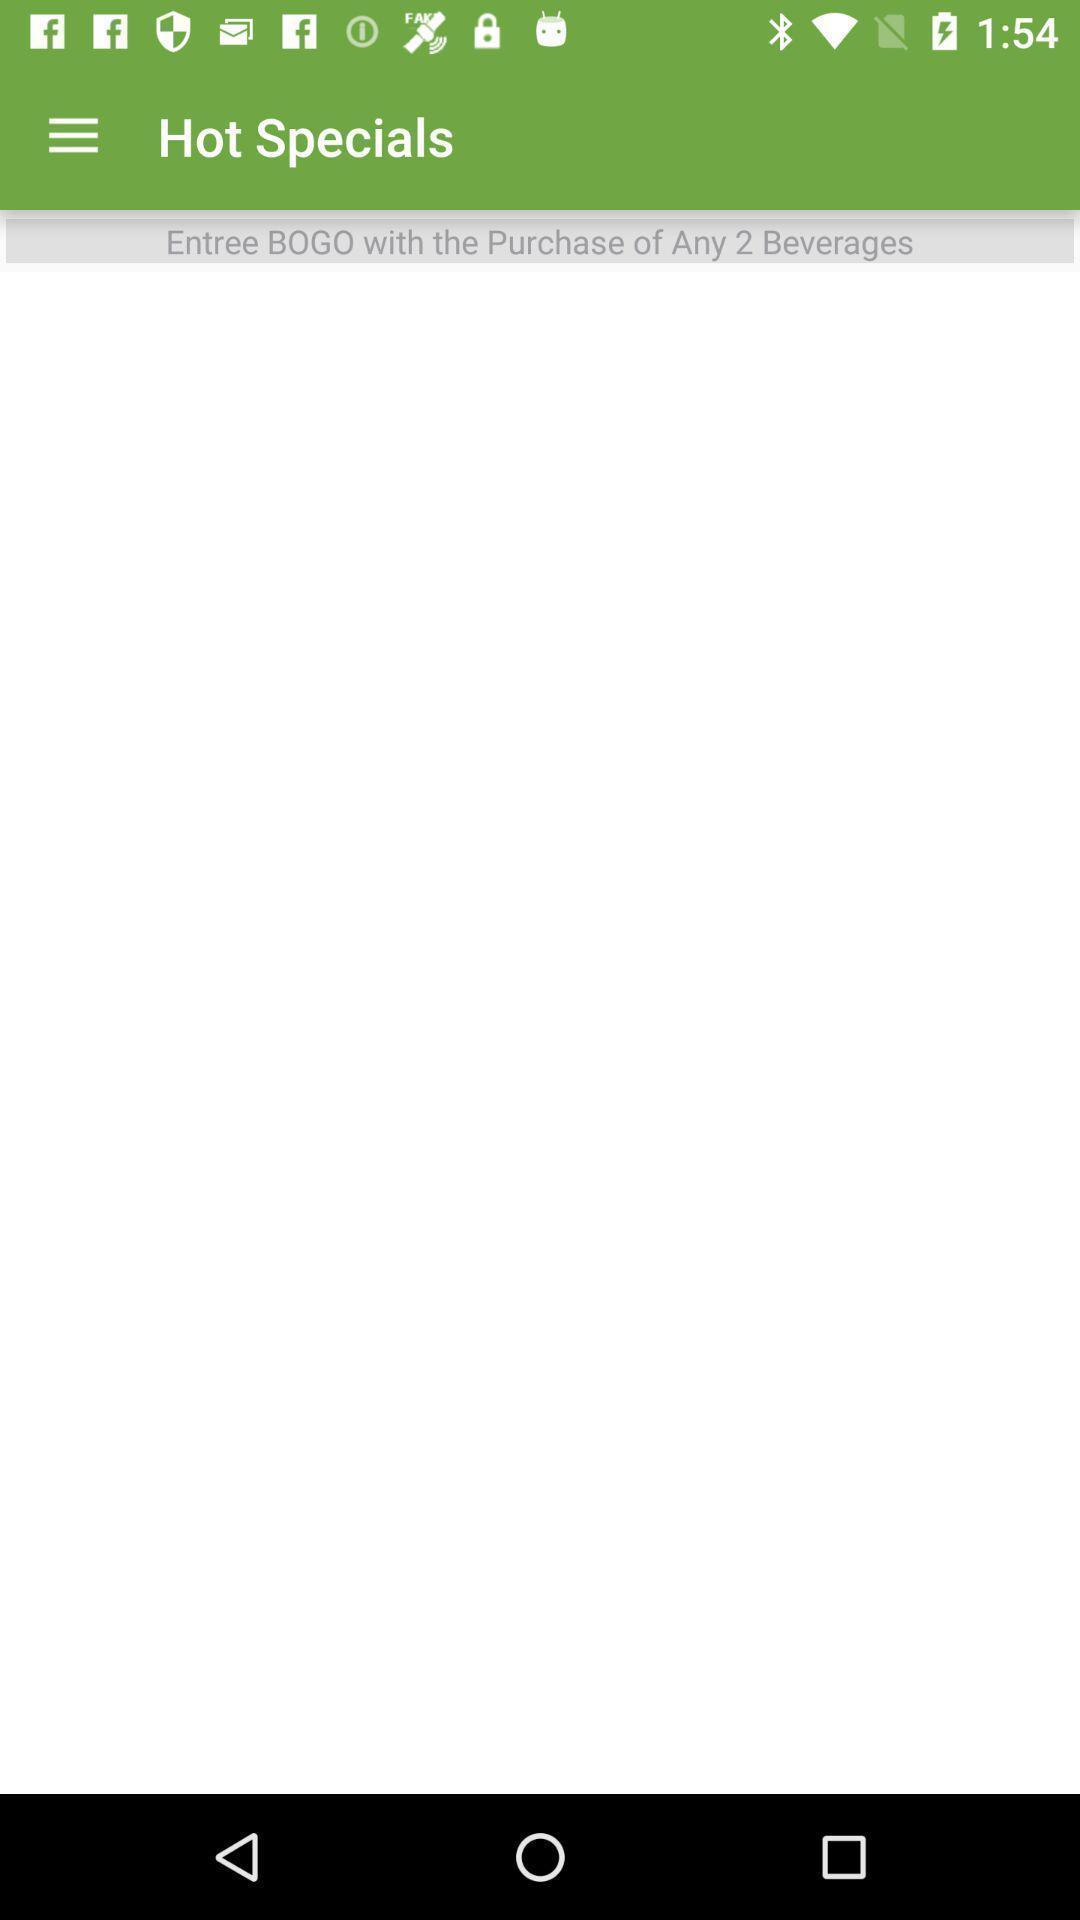What can you discern from this picture? Window displaying page for beverages. 